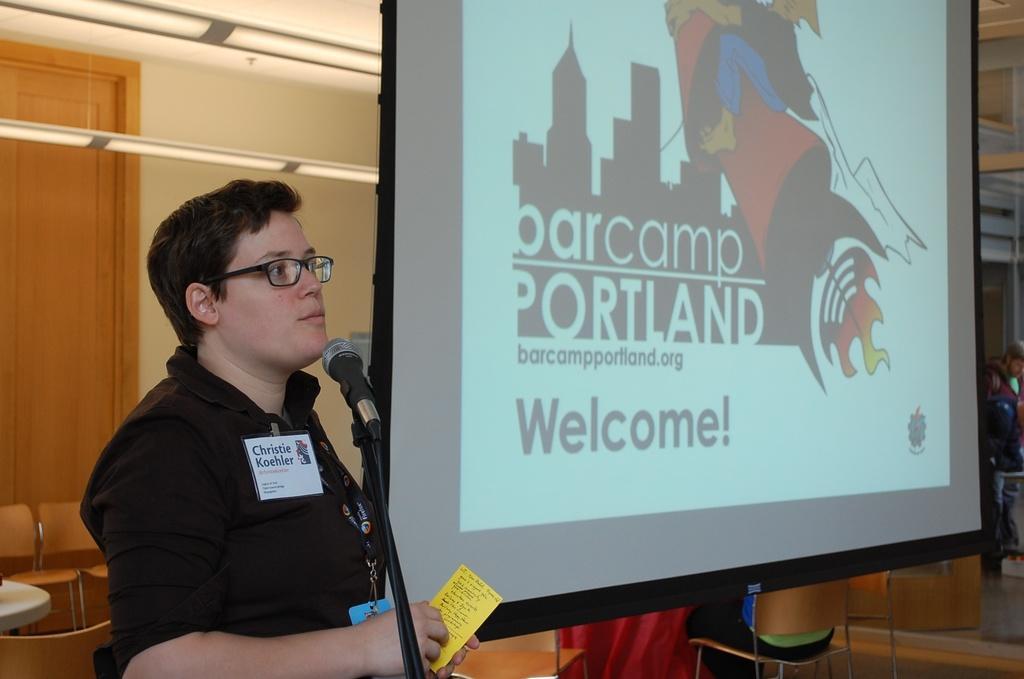In one or two sentences, can you explain what this image depicts? In this image I can see the person is wearing black color dress and holding the yellow card. I can see the mic, stand, few chairs, projection screen, wall and the door. 